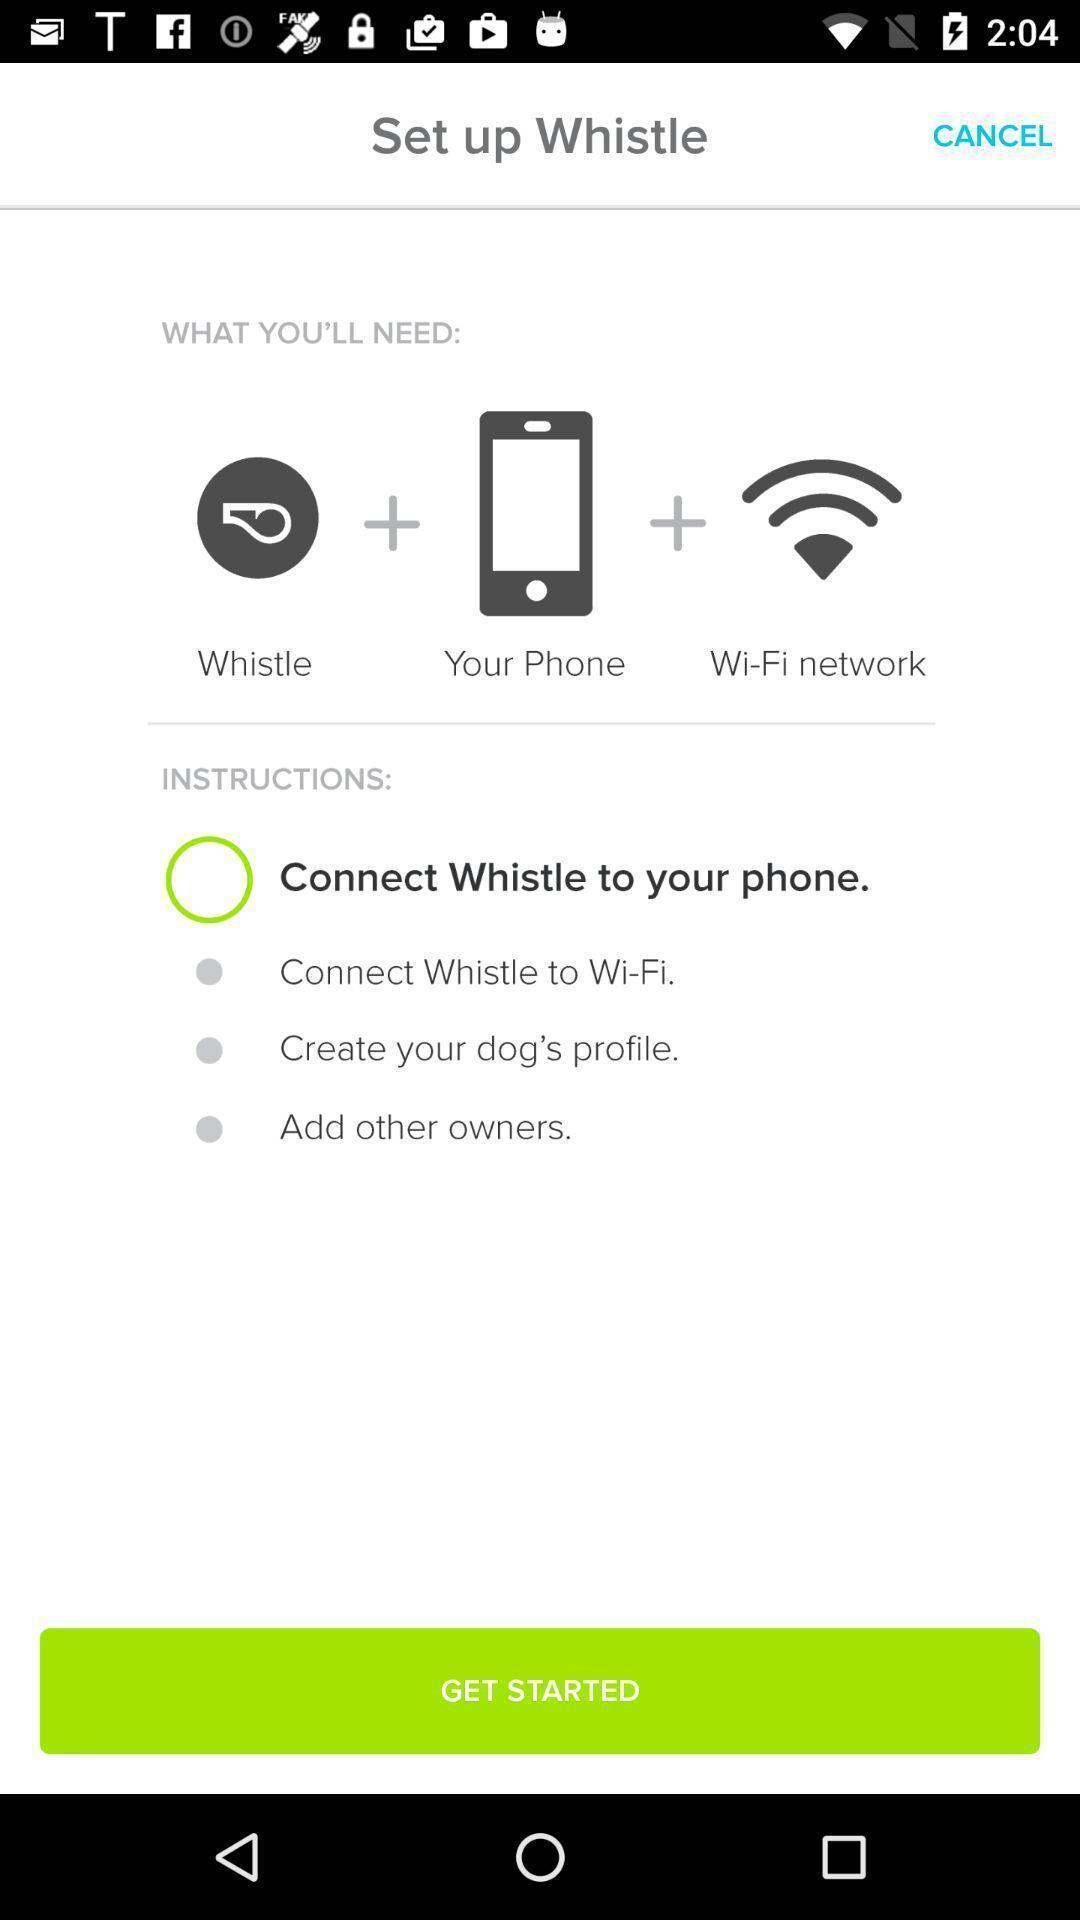Describe this image in words. Start page with instruction for connection. 